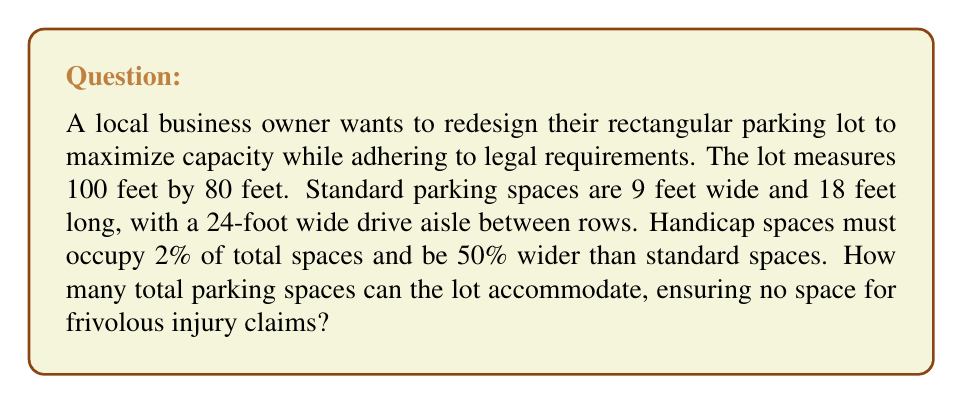Show me your answer to this math problem. Let's approach this step-by-step:

1) First, let's determine how many rows of parking we can fit:
   Lot width = 80 feet
   Two rows of parking (18 feet each) plus one drive aisle (24 feet) = 60 feet
   $$80 - 60 = 20$$ feet remaining, which is not enough for another full row.

2) Now, let's calculate how many standard spaces fit in each row:
   Lot length = 100 feet
   Standard space width = 9 feet
   $$100 \div 9 = 11.11$$
   We can fit 11 standard spaces per row.

3) Total standard spaces:
   $$11 \text{ spaces} \times 2 \text{ rows} = 22 \text{ spaces}$$

4) Calculate required handicap spaces:
   $$22 \times 0.02 = 0.44$$
   Round up to 1 handicap space

5) Handicap space width:
   $$9 \text{ feet} \times 1.5 = 13.5 \text{ feet}$$

6) Adjust the number of spaces in one row to accommodate the wider handicap space:
   $$100 - 13.5 = 86.5 \text{ feet remaining}$$
   $$86.5 \div 9 = 9.61$$
   We can fit 9 standard spaces plus 1 handicap space in this row

7) Final count:
   Row 1: 11 standard spaces
   Row 2: 9 standard spaces + 1 handicap space

Total spaces: $$11 + 9 + 1 = 21$$
Answer: 21 spaces 